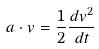Convert formula to latex. <formula><loc_0><loc_0><loc_500><loc_500>a \cdot v = \frac { 1 } { 2 } \frac { d v ^ { 2 } } { d t }</formula> 